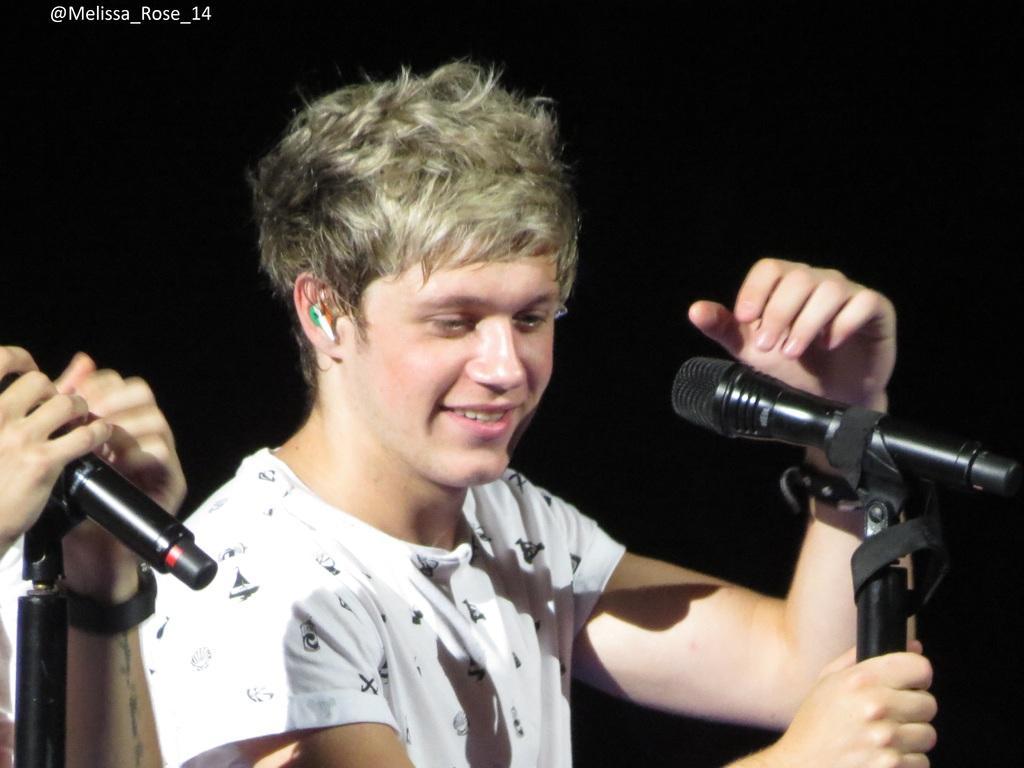Please provide a concise description of this image. In this image I see a man who is wearing white t-shirt and I see that he is holding the tripod and I see a mic on it and I see that he is smiling and I see a person holding this mic and I see the watermark over here and it is dark in the background. 